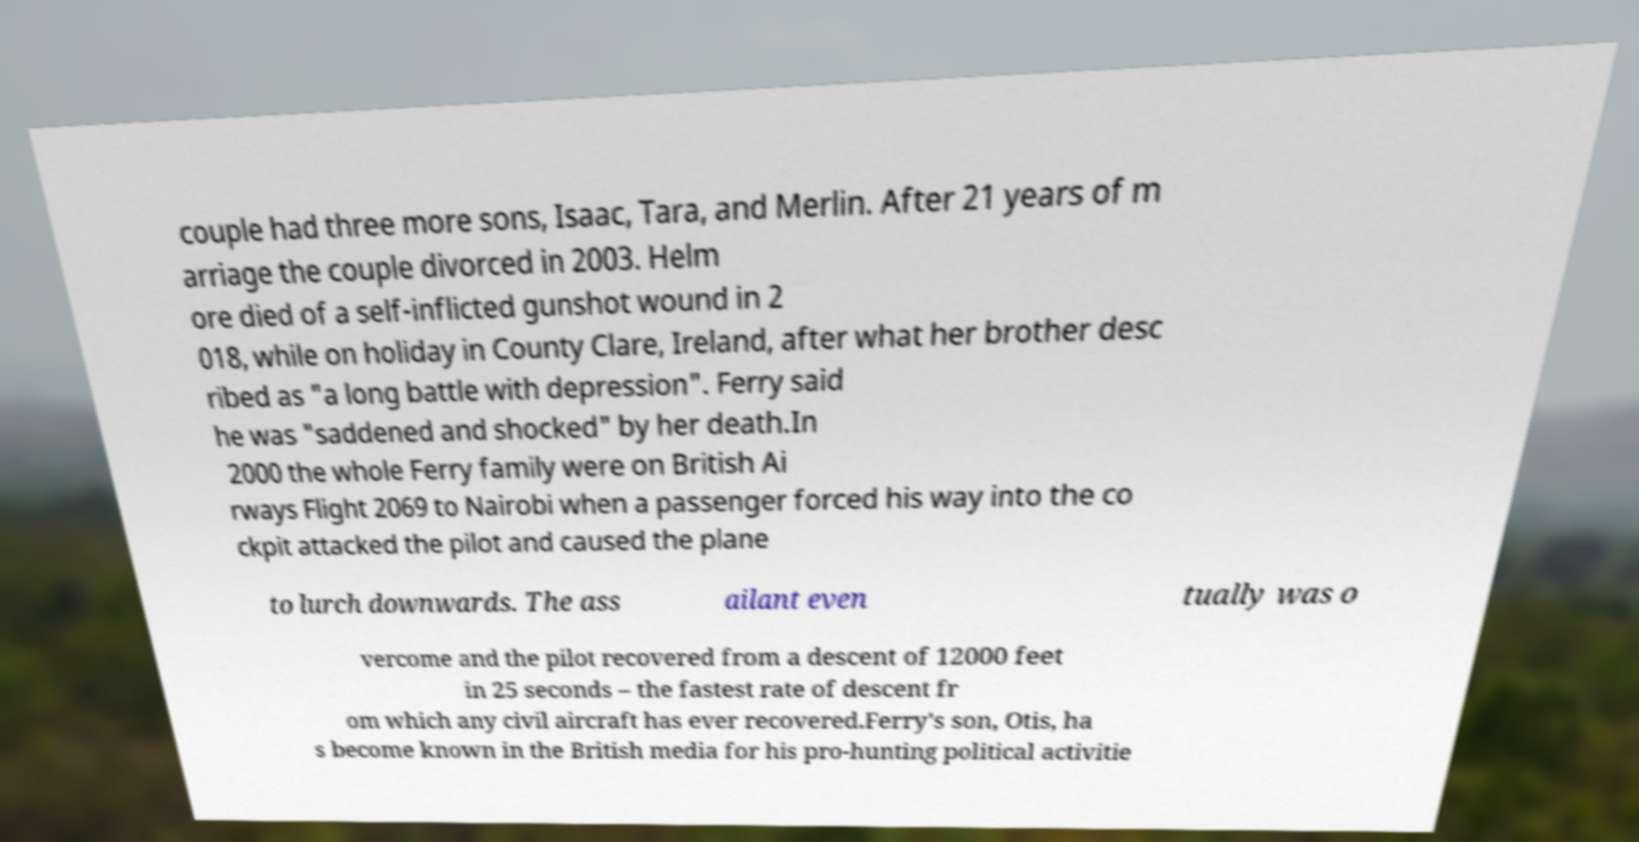Can you read and provide the text displayed in the image?This photo seems to have some interesting text. Can you extract and type it out for me? couple had three more sons, Isaac, Tara, and Merlin. After 21 years of m arriage the couple divorced in 2003. Helm ore died of a self-inflicted gunshot wound in 2 018, while on holiday in County Clare, Ireland, after what her brother desc ribed as "a long battle with depression". Ferry said he was "saddened and shocked" by her death.In 2000 the whole Ferry family were on British Ai rways Flight 2069 to Nairobi when a passenger forced his way into the co ckpit attacked the pilot and caused the plane to lurch downwards. The ass ailant even tually was o vercome and the pilot recovered from a descent of 12000 feet in 25 seconds – the fastest rate of descent fr om which any civil aircraft has ever recovered.Ferry's son, Otis, ha s become known in the British media for his pro-hunting political activitie 